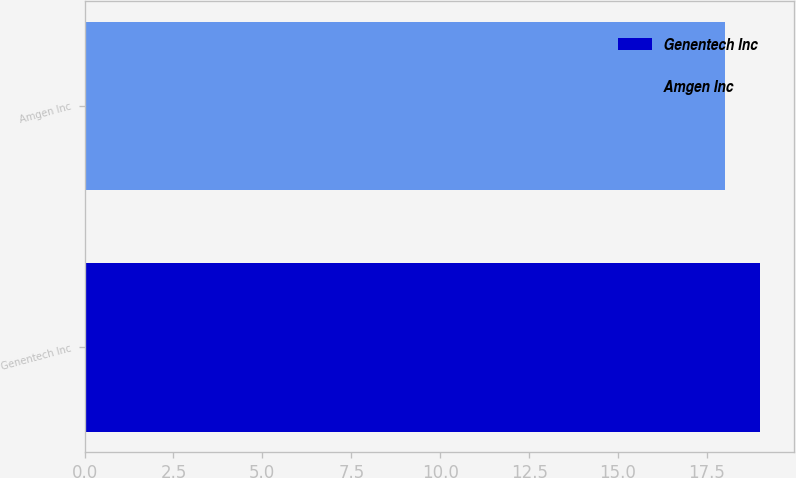<chart> <loc_0><loc_0><loc_500><loc_500><bar_chart><fcel>Genentech Inc<fcel>Amgen Inc<nl><fcel>19<fcel>18<nl></chart> 